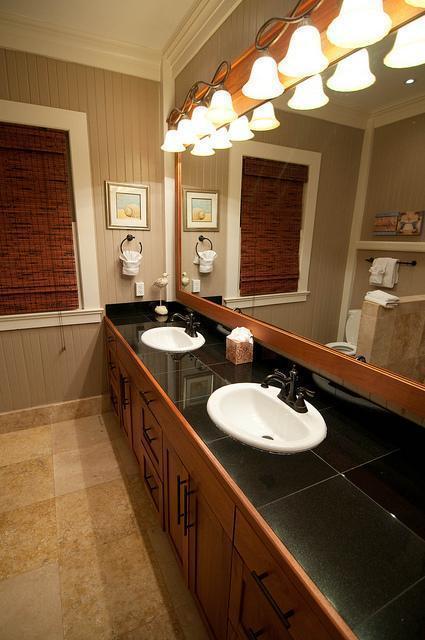What color are the sinks embedded in the black tile countertop?
Select the correct answer and articulate reasoning with the following format: 'Answer: answer
Rationale: rationale.'
Options: Blue, green, white, pink. Answer: white.
Rationale: A white.  they are obviously white. 